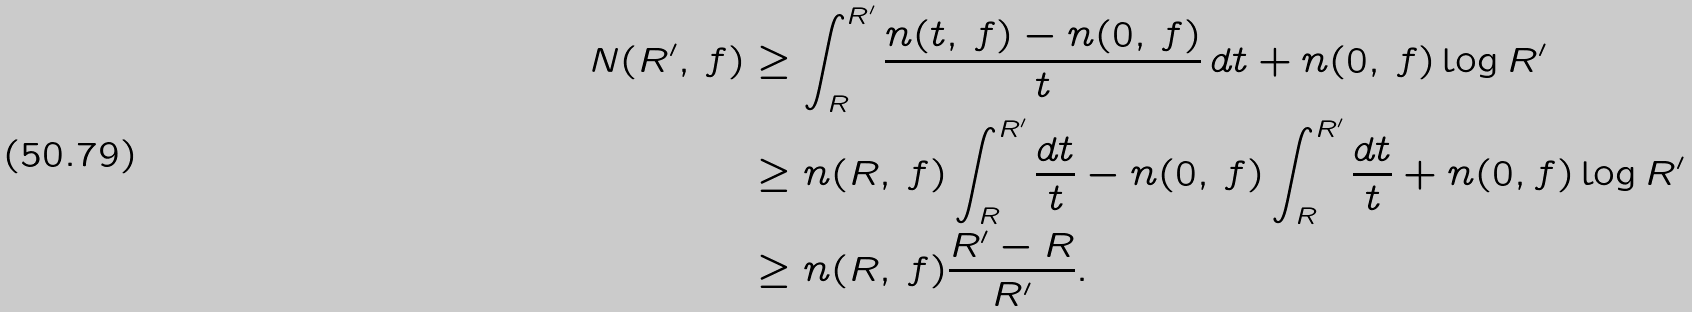<formula> <loc_0><loc_0><loc_500><loc_500>N ( R ^ { \prime } , \, f ) & \geq \int _ { R } ^ { R ^ { \prime } } \frac { n ( t , \, f ) - n ( 0 , \, f ) } { t } \, d t + n ( 0 , \, f ) \log R ^ { \prime } \\ & \geq n ( R , \, f ) \int _ { R } ^ { R ^ { \prime } } \frac { d t } { t } - n ( 0 , \, f ) \int _ { R } ^ { R ^ { \prime } } \frac { d t } { t } + n ( 0 , f ) \log R ^ { \prime } \\ & \geq n ( R , \, f ) \frac { R ^ { \prime } - R } { R ^ { \prime } } .</formula> 